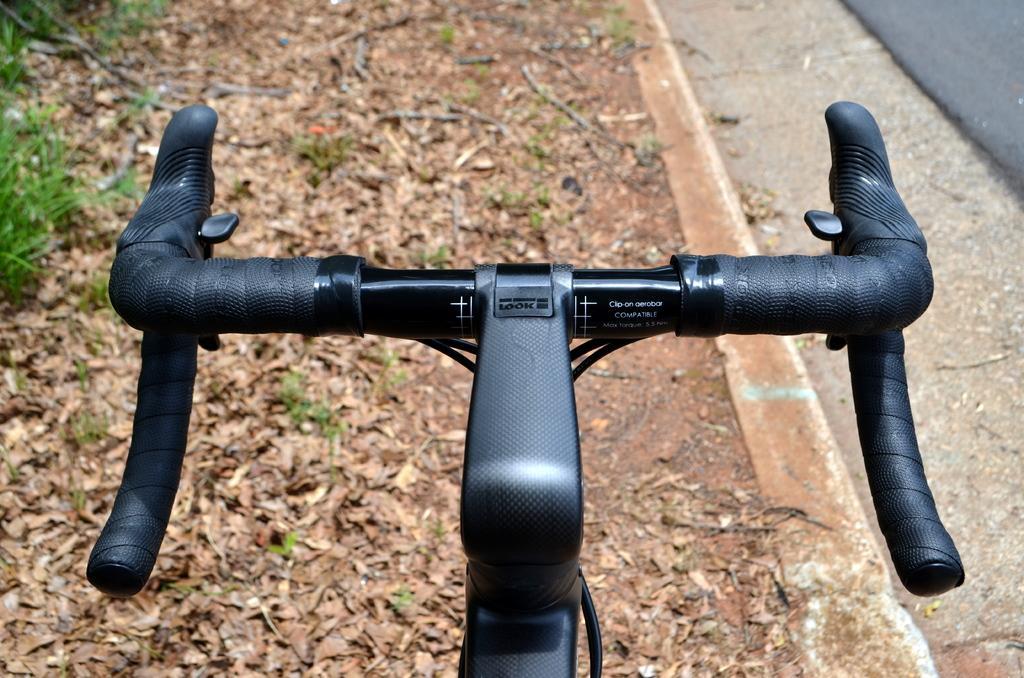Please provide a concise description of this image. In this image in front there is a bicycle. At the bottom of the image there are dried leaves. On the right side of the image there is a road. 